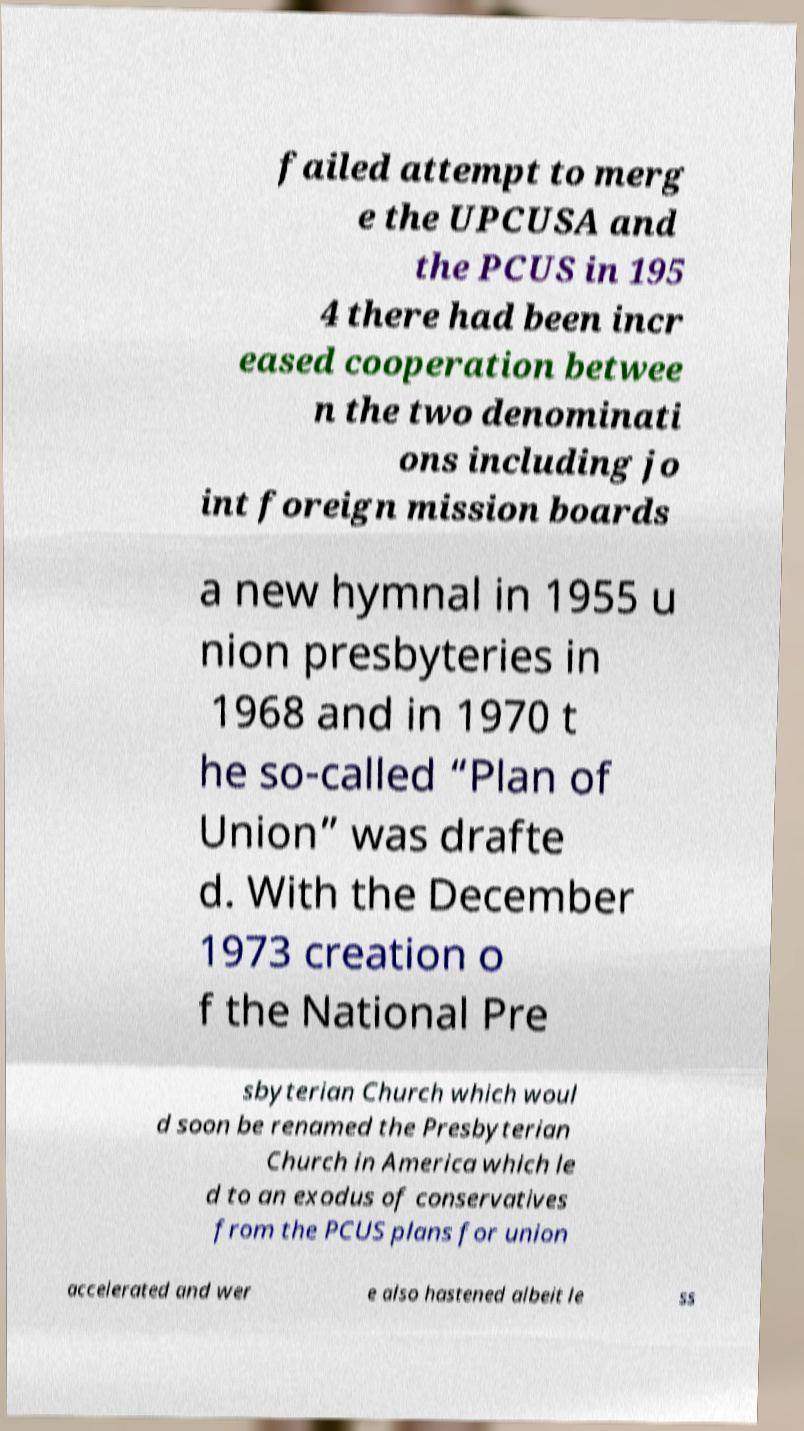Could you extract and type out the text from this image? failed attempt to merg e the UPCUSA and the PCUS in 195 4 there had been incr eased cooperation betwee n the two denominati ons including jo int foreign mission boards a new hymnal in 1955 u nion presbyteries in 1968 and in 1970 t he so-called “Plan of Union” was drafte d. With the December 1973 creation o f the National Pre sbyterian Church which woul d soon be renamed the Presbyterian Church in America which le d to an exodus of conservatives from the PCUS plans for union accelerated and wer e also hastened albeit le ss 